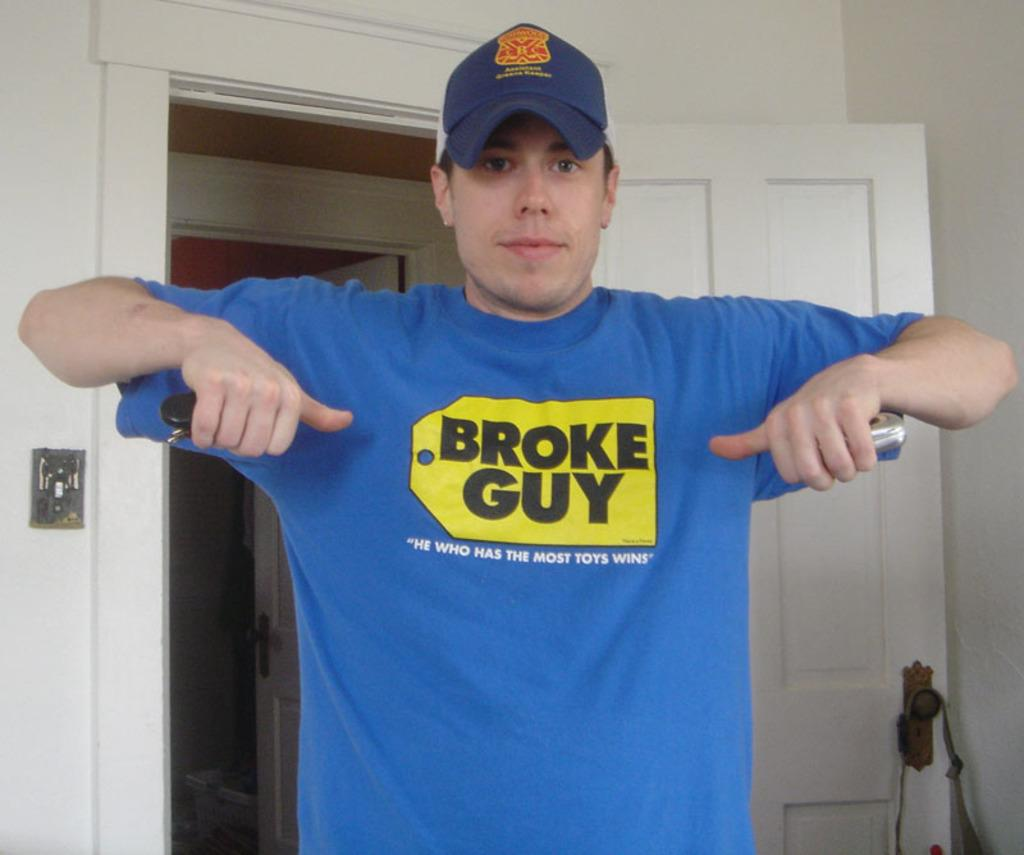<image>
Present a compact description of the photo's key features. A man is wearing a tee saying "broke guy" and points at the saying on his shirt. 